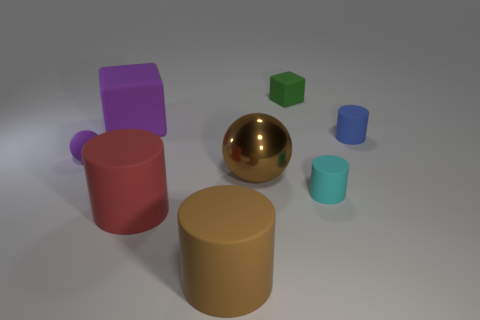Subtract all tiny cyan cylinders. How many cylinders are left? 3 Subtract all cyan cylinders. How many cylinders are left? 3 Subtract 1 blocks. How many blocks are left? 1 Add 2 big green cubes. How many objects exist? 10 Subtract all balls. How many objects are left? 6 Subtract all small blue rubber cylinders. Subtract all big rubber things. How many objects are left? 4 Add 6 large red cylinders. How many large red cylinders are left? 7 Add 3 green cubes. How many green cubes exist? 4 Subtract 0 yellow cubes. How many objects are left? 8 Subtract all brown cylinders. Subtract all green balls. How many cylinders are left? 3 